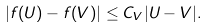<formula> <loc_0><loc_0><loc_500><loc_500>| f ( U ) - f ( V ) | \leq C _ { V } | U - V | .</formula> 